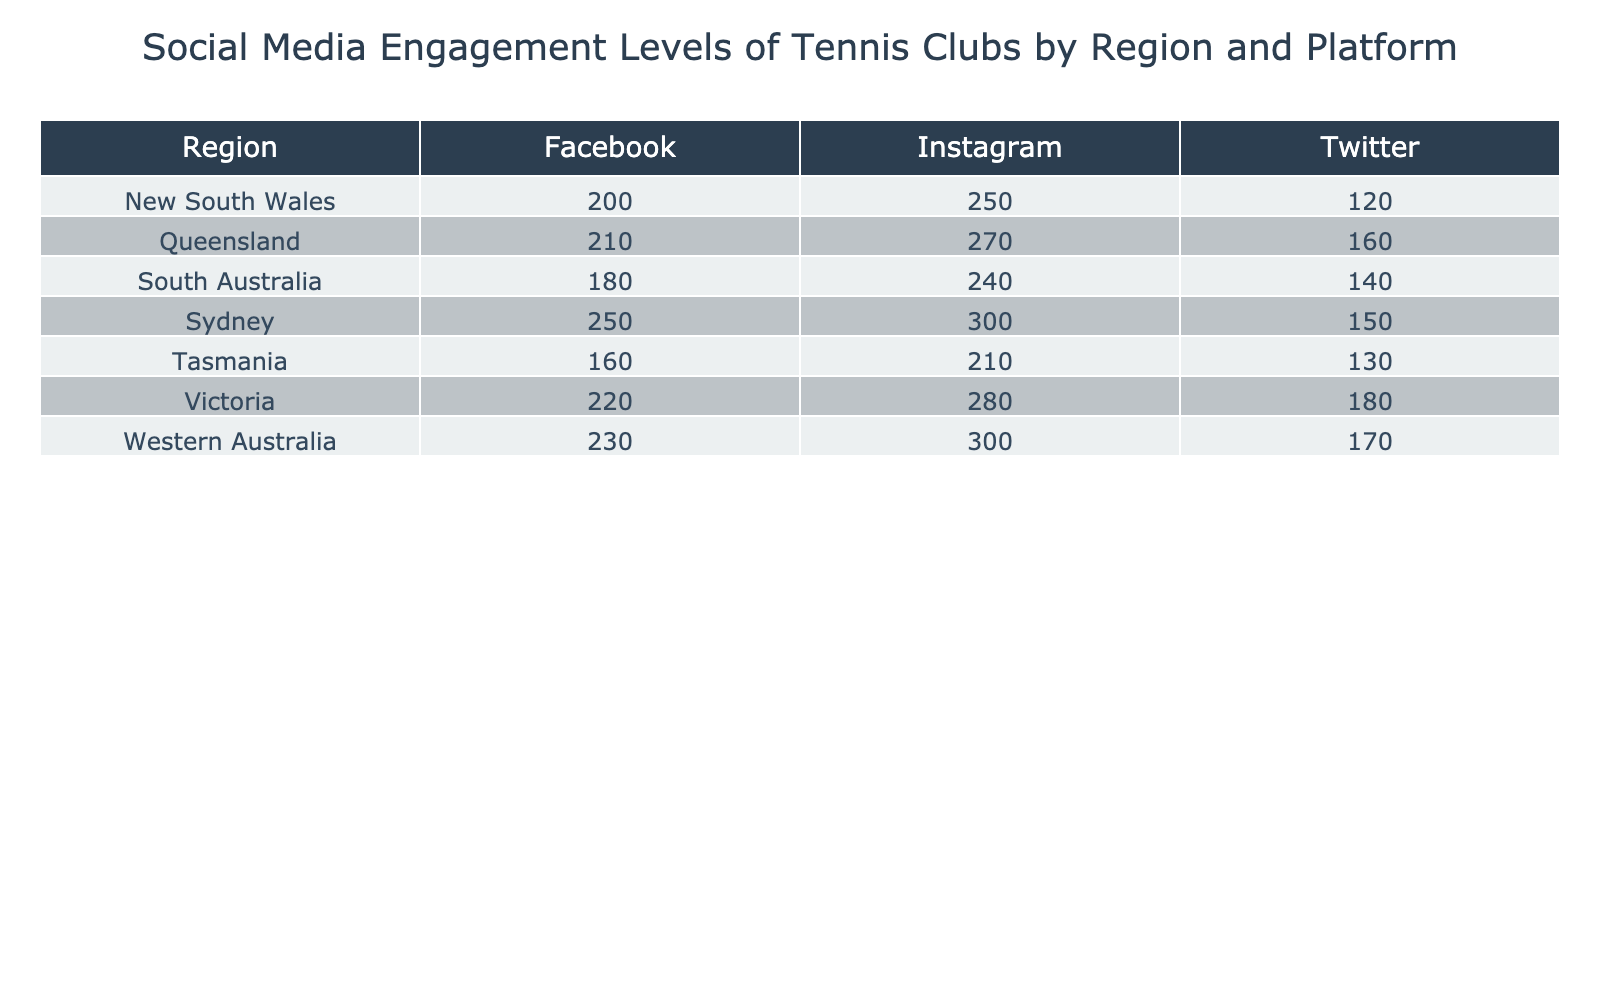What's the engagement level for tennis clubs in Sydney on Instagram? The table shows that under the "Sydney" row and the "Instagram" column, the engagement level is listed as 300.
Answer: 300 What is the total engagement level for New South Wales across all platforms? To find the total engagement for New South Wales, we add the engagement levels from all platforms: Facebook (200) + Instagram (250) + Twitter (120) = 570.
Answer: 570 Which platform has the highest engagement level in Queensland? By checking the engagement levels for Queensland, we see Facebook (210), Instagram (270), and Twitter (160). The highest among these is Instagram at 270.
Answer: Instagram Is the engagement level on Twitter for Victoria higher than that for South Australia? From the table, Victoria's Twitter engagement level is 180 and South Australia's is 140. Since 180 is greater than 140, the statement is true.
Answer: Yes What is the average engagement level for all platforms in Tasmania? In Tasmania, the engagement levels are Facebook (160), Instagram (210), and Twitter (130). The sum is 160 + 210 + 130 = 500. Dividing this by 3 gives an average of 500 / 3 = approximately 166.67.
Answer: 166.67 How does the total engagement level in Western Australia compare to that in Victoria? For Western Australia, the total is Facebook (230) + Instagram (300) + Twitter (170) = 700. For Victoria, the total is Facebook (220) + Instagram (280) + Twitter (180) = 680. Since 700 is greater than 680, Western Australia has a higher engagement level.
Answer: Western Australia is higher Which region has the lowest engagement on Twitter, and what is that level? Looking at the Twitter engagement levels for all regions, we compare: New South Wales (120), South Australia (140), Queensland (160), Tasmania (130), Sydney (150), Victoria (180), and Western Australia (170). The lowest is New South Wales at 120.
Answer: New South Wales, 120 What is the difference in engagement levels between Instagram and Facebook for all regions combined? First, we calculate the engagement levels: for Instagram: 300 + 250 + 280 + 270 + 300 + 240 + 210 = 2100. For Facebook: 250 + 200 + 220 + 210 + 230 + 180 + 160 = 1450. Now, we find the difference: 2100 - 1450 = 650.
Answer: 650 